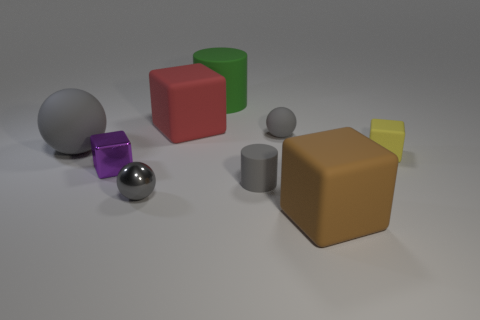What is the mood or atmosphere that this arrangement of shapes conveys? The image presents a calm and orderly atmosphere, with the neutral background and soft lighting. The arrangement of various shapes in different sizes and colors seems to have been done with a sense of balance and symmetry, creating a scene that's pleasing to the eye and invokes a tranquil, almost studious, environment. 